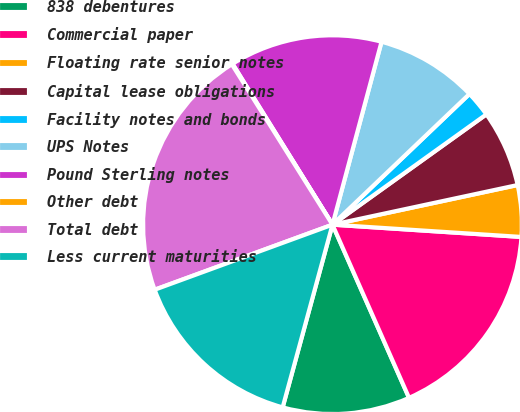Convert chart to OTSL. <chart><loc_0><loc_0><loc_500><loc_500><pie_chart><fcel>838 debentures<fcel>Commercial paper<fcel>Floating rate senior notes<fcel>Capital lease obligations<fcel>Facility notes and bonds<fcel>UPS Notes<fcel>Pound Sterling notes<fcel>Other debt<fcel>Total debt<fcel>Less current maturities<nl><fcel>10.86%<fcel>17.34%<fcel>4.39%<fcel>6.54%<fcel>2.23%<fcel>8.7%<fcel>13.02%<fcel>0.07%<fcel>21.66%<fcel>15.18%<nl></chart> 